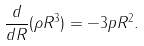<formula> <loc_0><loc_0><loc_500><loc_500>\frac { d } { d R } ( \rho R ^ { 3 } ) = - 3 p R ^ { 2 } .</formula> 